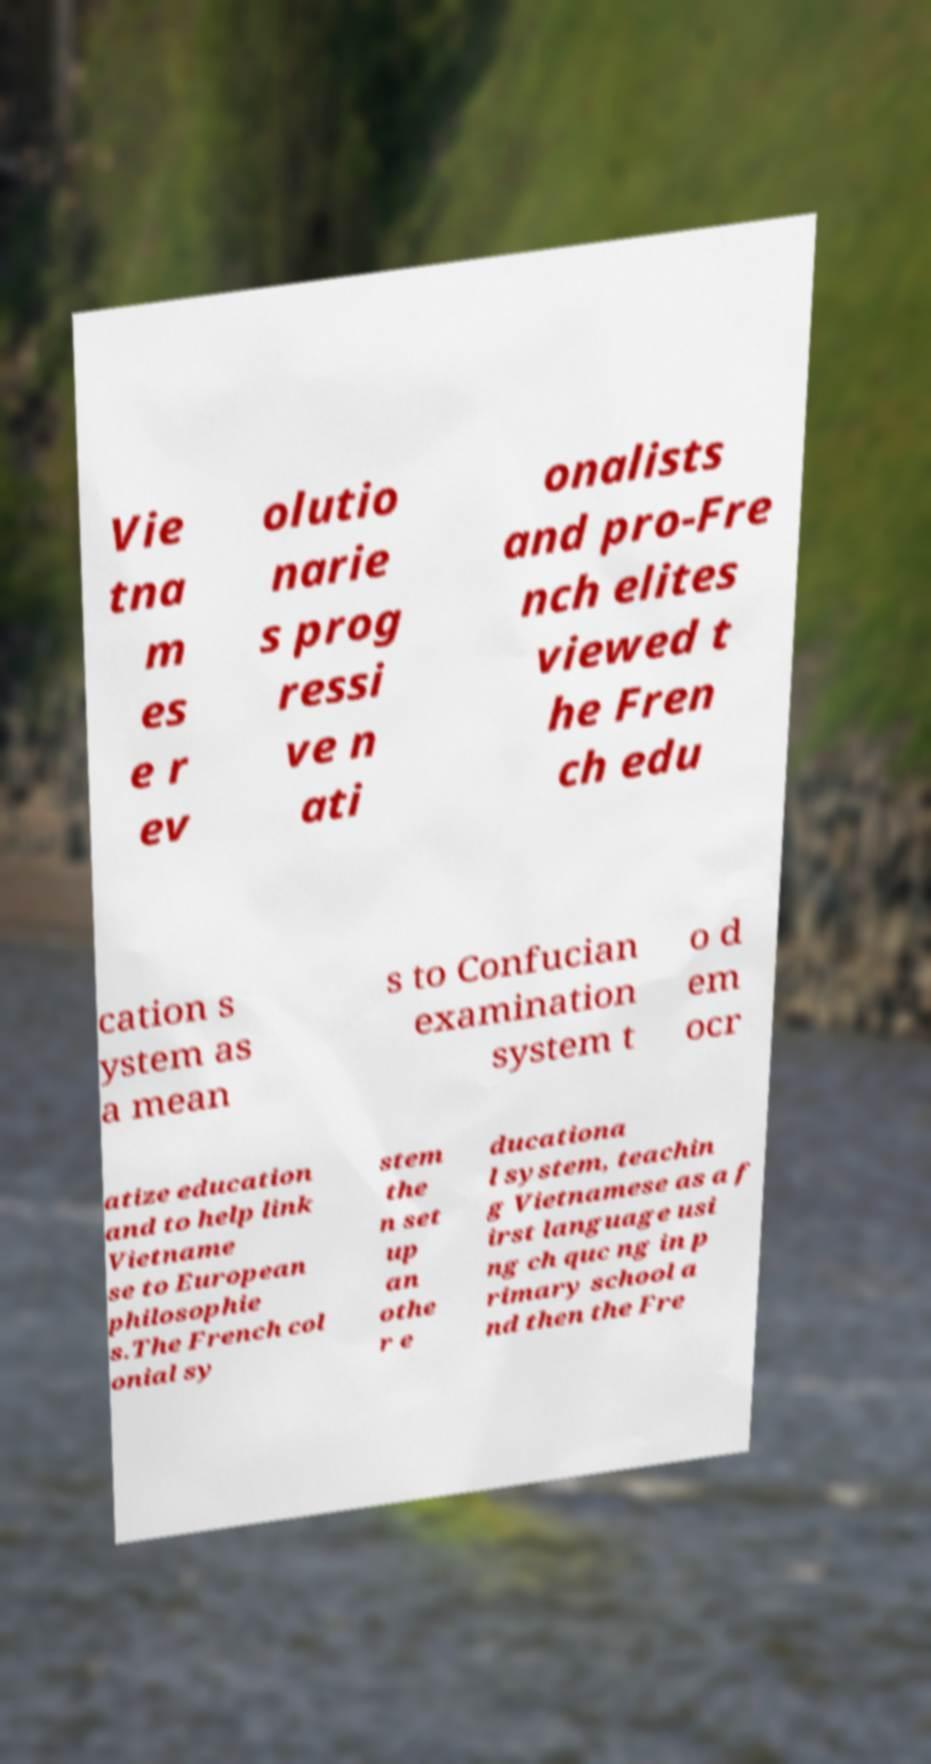For documentation purposes, I need the text within this image transcribed. Could you provide that? Vie tna m es e r ev olutio narie s prog ressi ve n ati onalists and pro-Fre nch elites viewed t he Fren ch edu cation s ystem as a mean s to Confucian examination system t o d em ocr atize education and to help link Vietname se to European philosophie s.The French col onial sy stem the n set up an othe r e ducationa l system, teachin g Vietnamese as a f irst language usi ng ch quc ng in p rimary school a nd then the Fre 